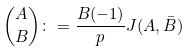<formula> <loc_0><loc_0><loc_500><loc_500>\binom { A } { B } \colon = \frac { B ( - 1 ) } { p } J ( A , \bar { B } )</formula> 